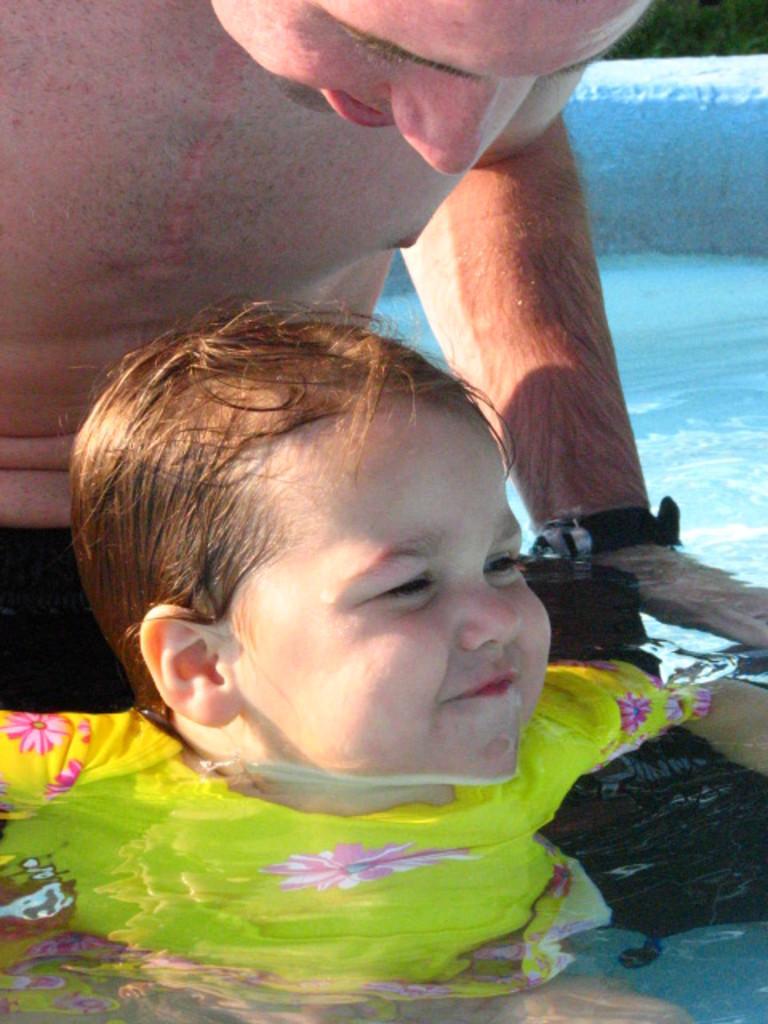Can you describe this image briefly? In the image there is a baby and a man in a pool. 